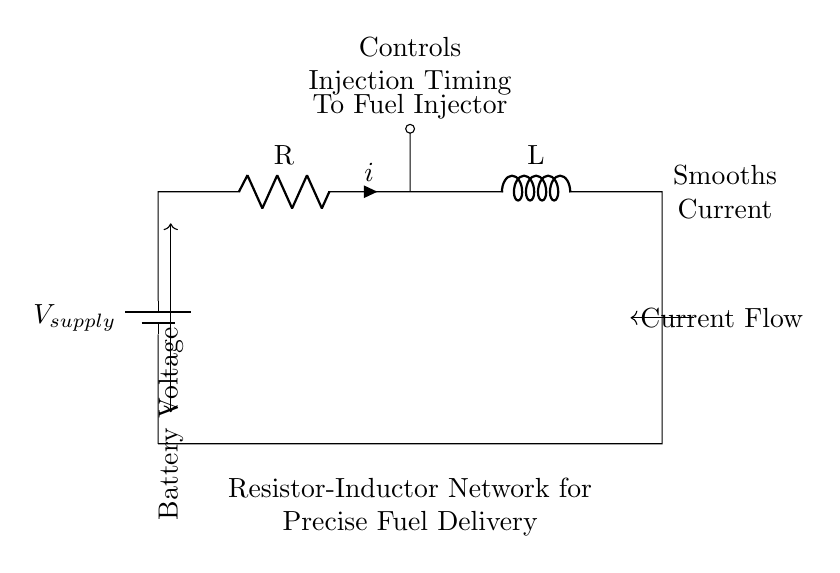What type of components are in this circuit? The circuit contains a resistor and an inductor, which are the two main components shown in the diagram.
Answer: Resistor and Inductor What does the resistor do in this circuit? The resistor limits the current flowing through the circuit, ensuring that the fuel injector receives a controlled amount of current for precise operation.
Answer: Limits current What role does the inductor play in the circuit? The inductor smooths the current flow in the circuit, which helps in maintaining a steady operation of the fuel injector during its timing cycles.
Answer: Smooths current What is the purpose of this network in motorcycle fuel injection? The purpose of the resistor-inductor network is to precisely control fuel delivery timing, which is crucial for optimal engine performance and efficiency.
Answer: Precise fuel delivery How is the battery voltage indicated in the circuit? The battery voltage is indicated by the arrow pointing to the left of the battery symbol within the circuit diagram, showing its role as the supply voltage.
Answer: Battery voltage What does the arrow indicating current flow signify? The arrow indicating current flow shows the direction in which electrical current travels through the circuit, from the battery through the resistor and inductor to the fuel injector.
Answer: Current flow direction 